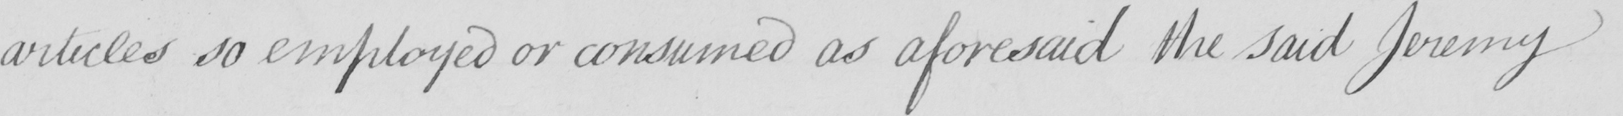Can you tell me what this handwritten text says? articles so employed or consumed as aforesaid the said Jeremy 